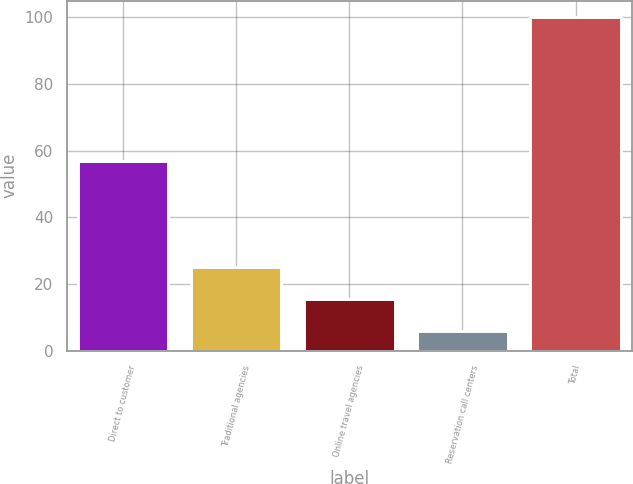<chart> <loc_0><loc_0><loc_500><loc_500><bar_chart><fcel>Direct to customer<fcel>Traditional agencies<fcel>Online travel agencies<fcel>Reservation call centers<fcel>Total<nl><fcel>57<fcel>25<fcel>15.4<fcel>6<fcel>100<nl></chart> 